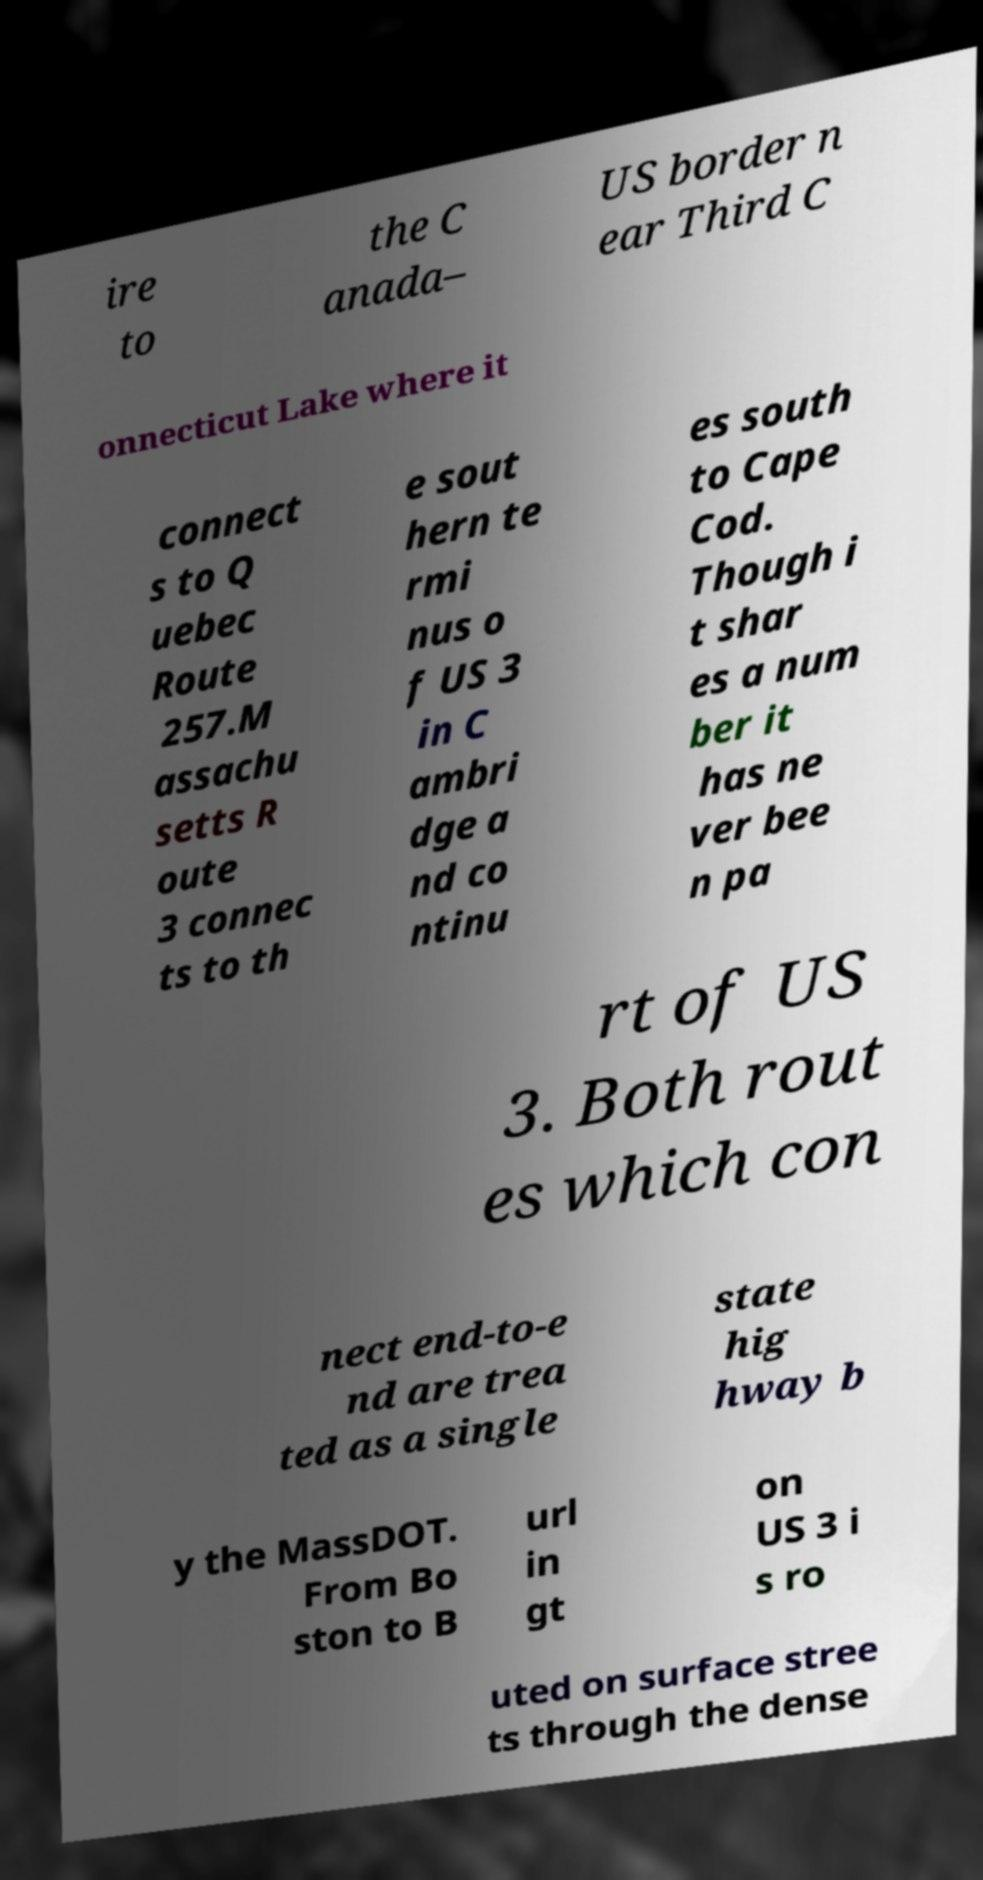Can you accurately transcribe the text from the provided image for me? ire to the C anada– US border n ear Third C onnecticut Lake where it connect s to Q uebec Route 257.M assachu setts R oute 3 connec ts to th e sout hern te rmi nus o f US 3 in C ambri dge a nd co ntinu es south to Cape Cod. Though i t shar es a num ber it has ne ver bee n pa rt of US 3. Both rout es which con nect end-to-e nd are trea ted as a single state hig hway b y the MassDOT. From Bo ston to B url in gt on US 3 i s ro uted on surface stree ts through the dense 